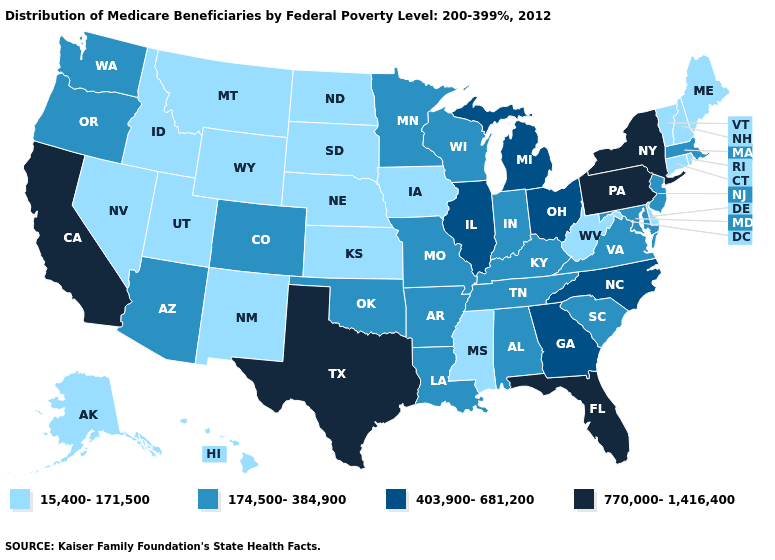Name the states that have a value in the range 15,400-171,500?
Give a very brief answer. Alaska, Connecticut, Delaware, Hawaii, Idaho, Iowa, Kansas, Maine, Mississippi, Montana, Nebraska, Nevada, New Hampshire, New Mexico, North Dakota, Rhode Island, South Dakota, Utah, Vermont, West Virginia, Wyoming. Is the legend a continuous bar?
Concise answer only. No. What is the lowest value in the MidWest?
Give a very brief answer. 15,400-171,500. What is the value of Arkansas?
Keep it brief. 174,500-384,900. Does Ohio have a higher value than New York?
Short answer required. No. Does California have the highest value in the USA?
Concise answer only. Yes. Which states hav the highest value in the West?
Short answer required. California. Does Montana have the lowest value in the West?
Write a very short answer. Yes. Is the legend a continuous bar?
Keep it brief. No. What is the value of Montana?
Write a very short answer. 15,400-171,500. Among the states that border Georgia , does South Carolina have the lowest value?
Give a very brief answer. Yes. How many symbols are there in the legend?
Write a very short answer. 4. Does Mississippi have the lowest value in the South?
Write a very short answer. Yes. Name the states that have a value in the range 770,000-1,416,400?
Be succinct. California, Florida, New York, Pennsylvania, Texas. Does Arizona have the lowest value in the West?
Concise answer only. No. 